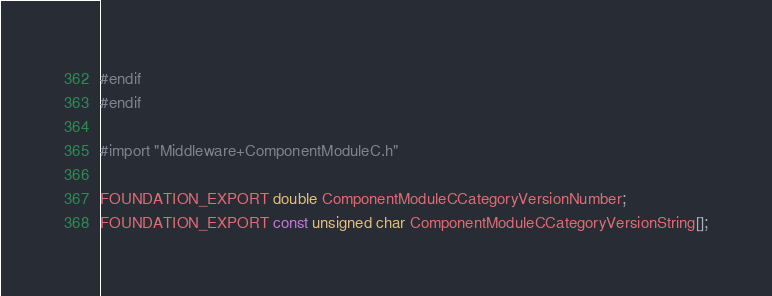Convert code to text. <code><loc_0><loc_0><loc_500><loc_500><_C_>#endif
#endif

#import "Middleware+ComponentModuleC.h"

FOUNDATION_EXPORT double ComponentModuleCCategoryVersionNumber;
FOUNDATION_EXPORT const unsigned char ComponentModuleCCategoryVersionString[];

</code> 